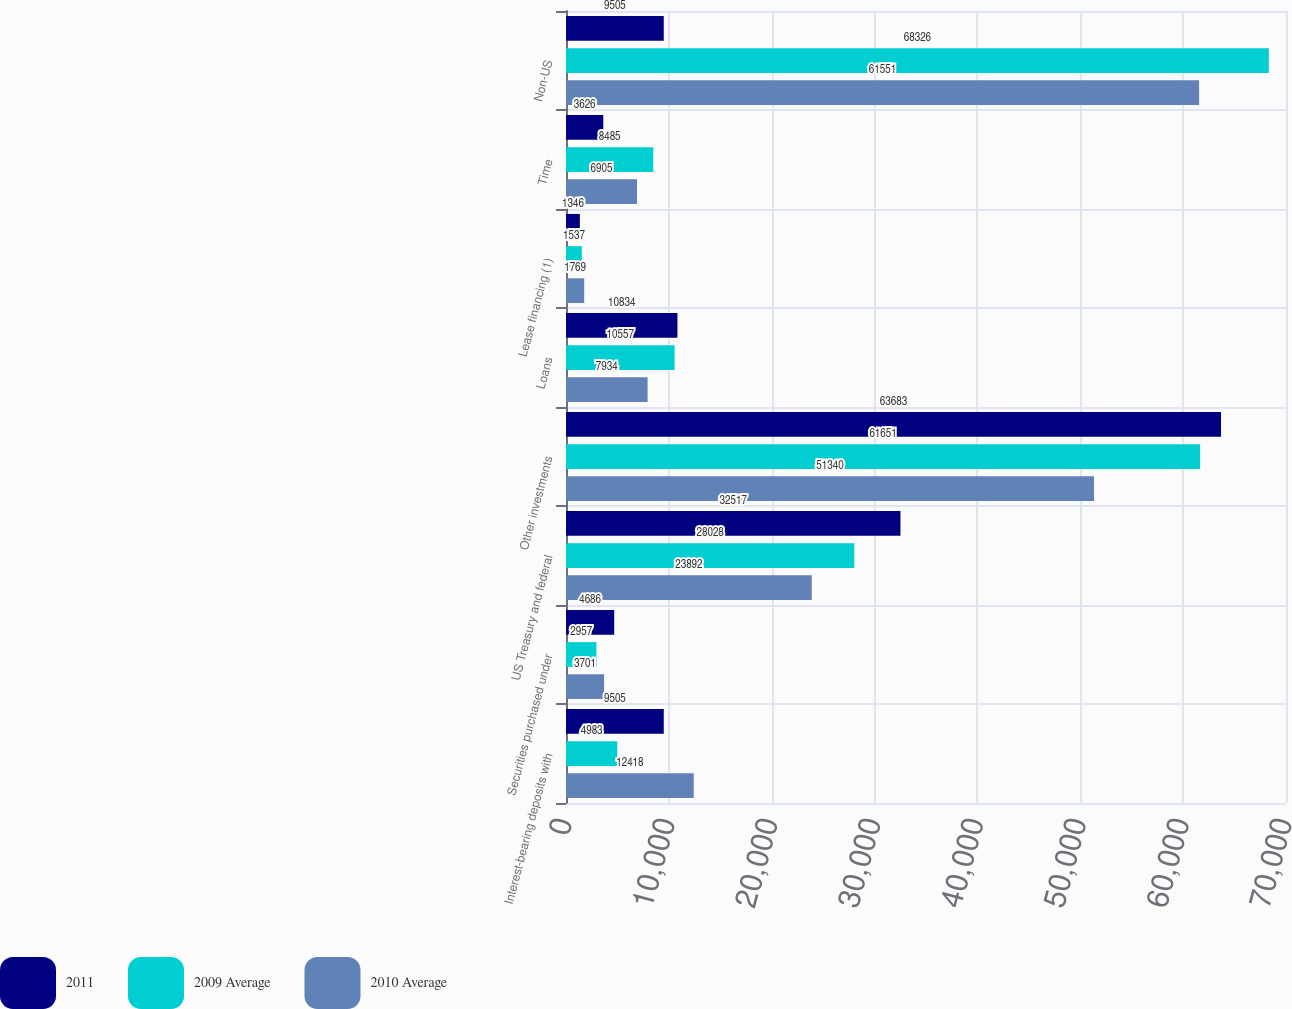Convert chart to OTSL. <chart><loc_0><loc_0><loc_500><loc_500><stacked_bar_chart><ecel><fcel>Interest-bearing deposits with<fcel>Securities purchased under<fcel>US Treasury and federal<fcel>Other investments<fcel>Loans<fcel>Lease financing (1)<fcel>Time<fcel>Non-US<nl><fcel>2011<fcel>9505<fcel>4686<fcel>32517<fcel>63683<fcel>10834<fcel>1346<fcel>3626<fcel>9505<nl><fcel>2009 Average<fcel>4983<fcel>2957<fcel>28028<fcel>61651<fcel>10557<fcel>1537<fcel>8485<fcel>68326<nl><fcel>2010 Average<fcel>12418<fcel>3701<fcel>23892<fcel>51340<fcel>7934<fcel>1769<fcel>6905<fcel>61551<nl></chart> 